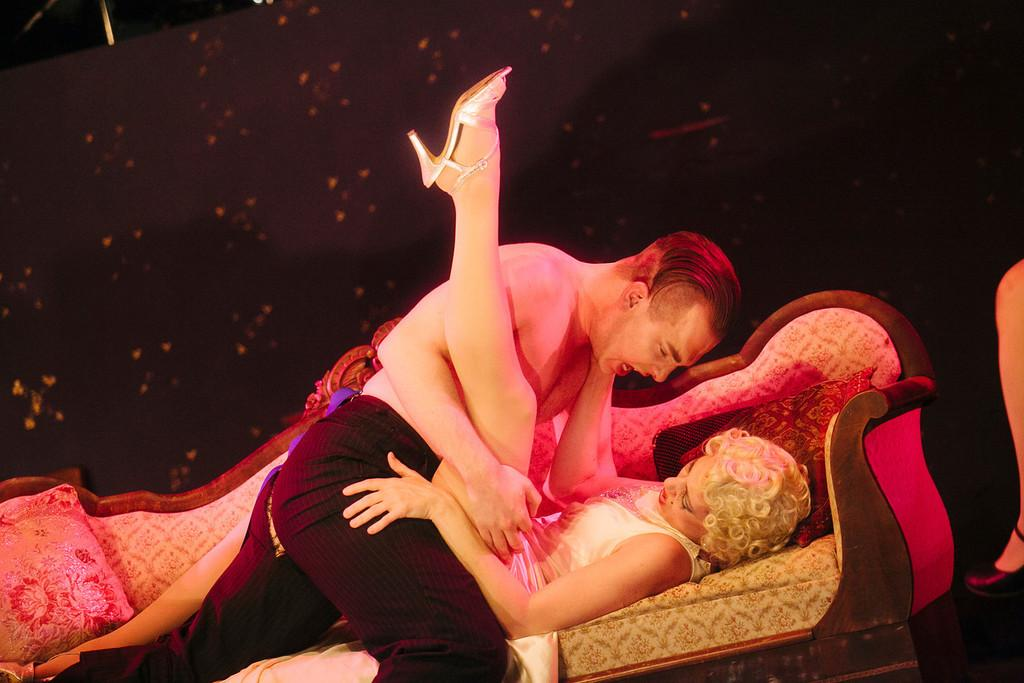Who are the two people in the image? There is a boy and a girl in the image. Where are the boy and girl located in the image? They are in the center of the image. What are they sitting on? They are sitting on a sofa. What type of basket is being used by the boy and girl in the image? There is no basket present in the image; the boy and girl are sitting on a sofa. 